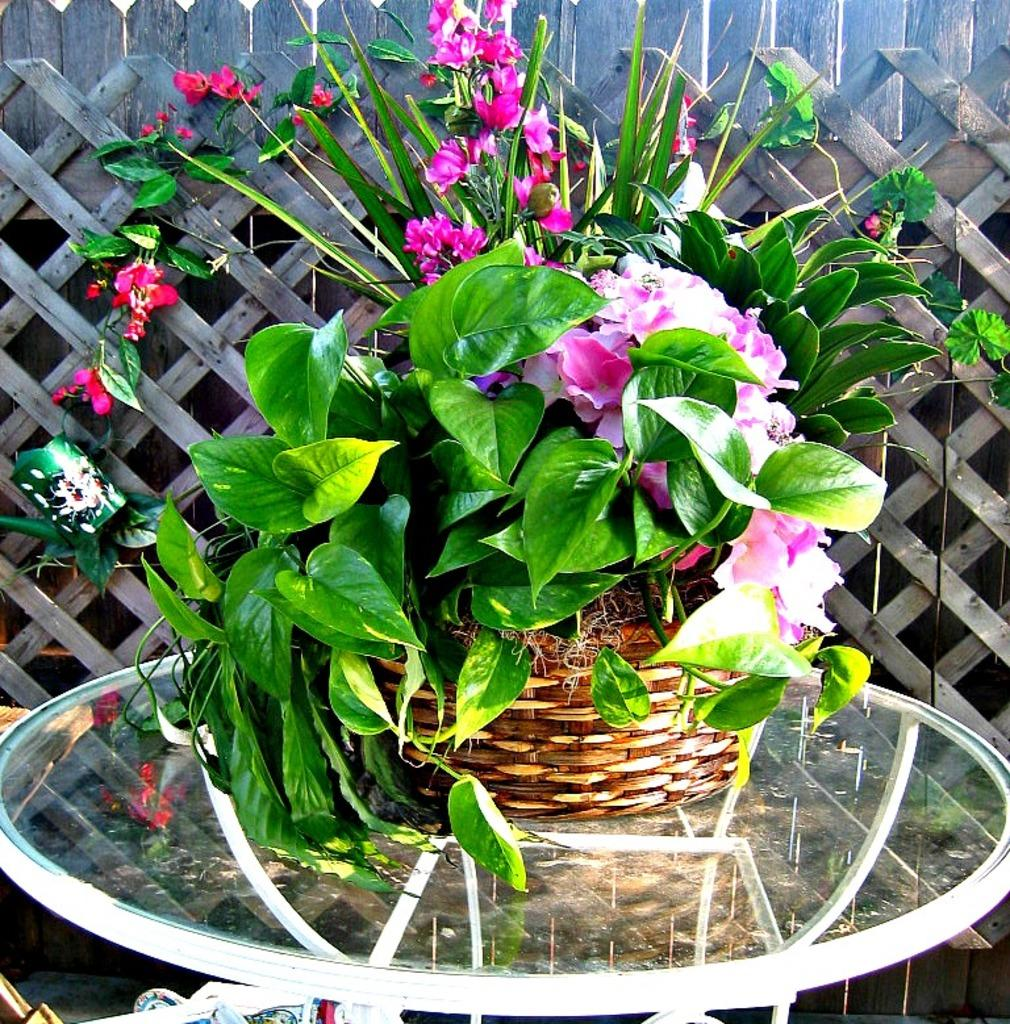What is located in the foreground of the image? There is a flower vase in the foreground of the image. What is the flower vase placed on? The flower vase is on a glass table. What type of material can be seen in the background of the image? There is a wooden wall in the background of the image. How many sisters are sitting on the wooden wall in the image? There are no sisters present in the image; it only features a flower vase on a glass table with a wooden wall in the background. 